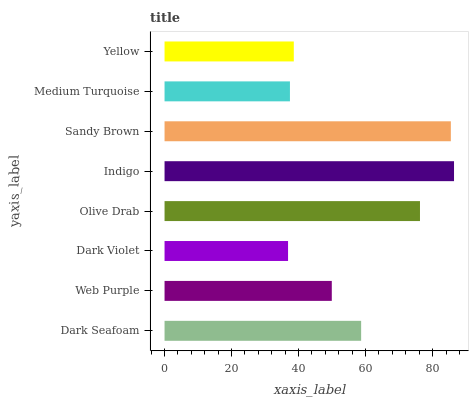Is Dark Violet the minimum?
Answer yes or no. Yes. Is Indigo the maximum?
Answer yes or no. Yes. Is Web Purple the minimum?
Answer yes or no. No. Is Web Purple the maximum?
Answer yes or no. No. Is Dark Seafoam greater than Web Purple?
Answer yes or no. Yes. Is Web Purple less than Dark Seafoam?
Answer yes or no. Yes. Is Web Purple greater than Dark Seafoam?
Answer yes or no. No. Is Dark Seafoam less than Web Purple?
Answer yes or no. No. Is Dark Seafoam the high median?
Answer yes or no. Yes. Is Web Purple the low median?
Answer yes or no. Yes. Is Olive Drab the high median?
Answer yes or no. No. Is Indigo the low median?
Answer yes or no. No. 